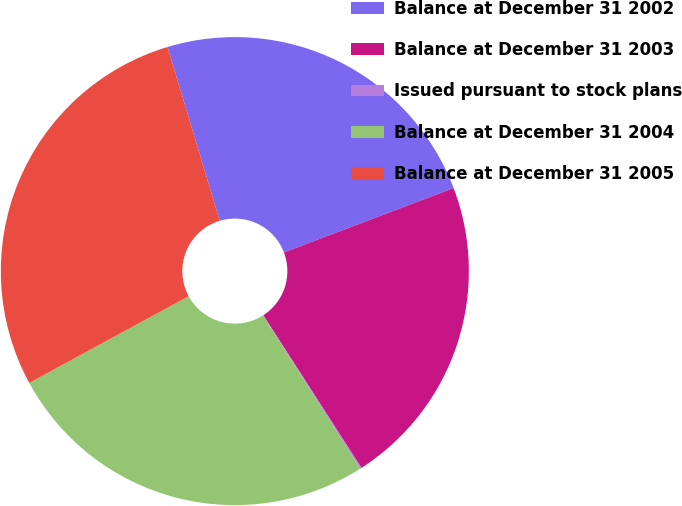Convert chart. <chart><loc_0><loc_0><loc_500><loc_500><pie_chart><fcel>Balance at December 31 2002<fcel>Balance at December 31 2003<fcel>Issued pursuant to stock plans<fcel>Balance at December 31 2004<fcel>Balance at December 31 2005<nl><fcel>23.87%<fcel>21.67%<fcel>0.1%<fcel>26.07%<fcel>28.28%<nl></chart> 